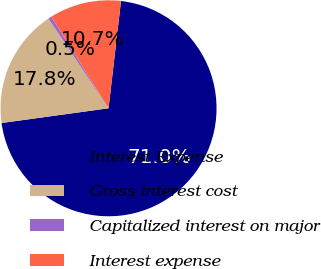Convert chart to OTSL. <chart><loc_0><loc_0><loc_500><loc_500><pie_chart><fcel>Interest Expense<fcel>Gross interest cost<fcel>Capitalized interest on major<fcel>Interest expense<nl><fcel>70.97%<fcel>17.79%<fcel>0.49%<fcel>10.74%<nl></chart> 